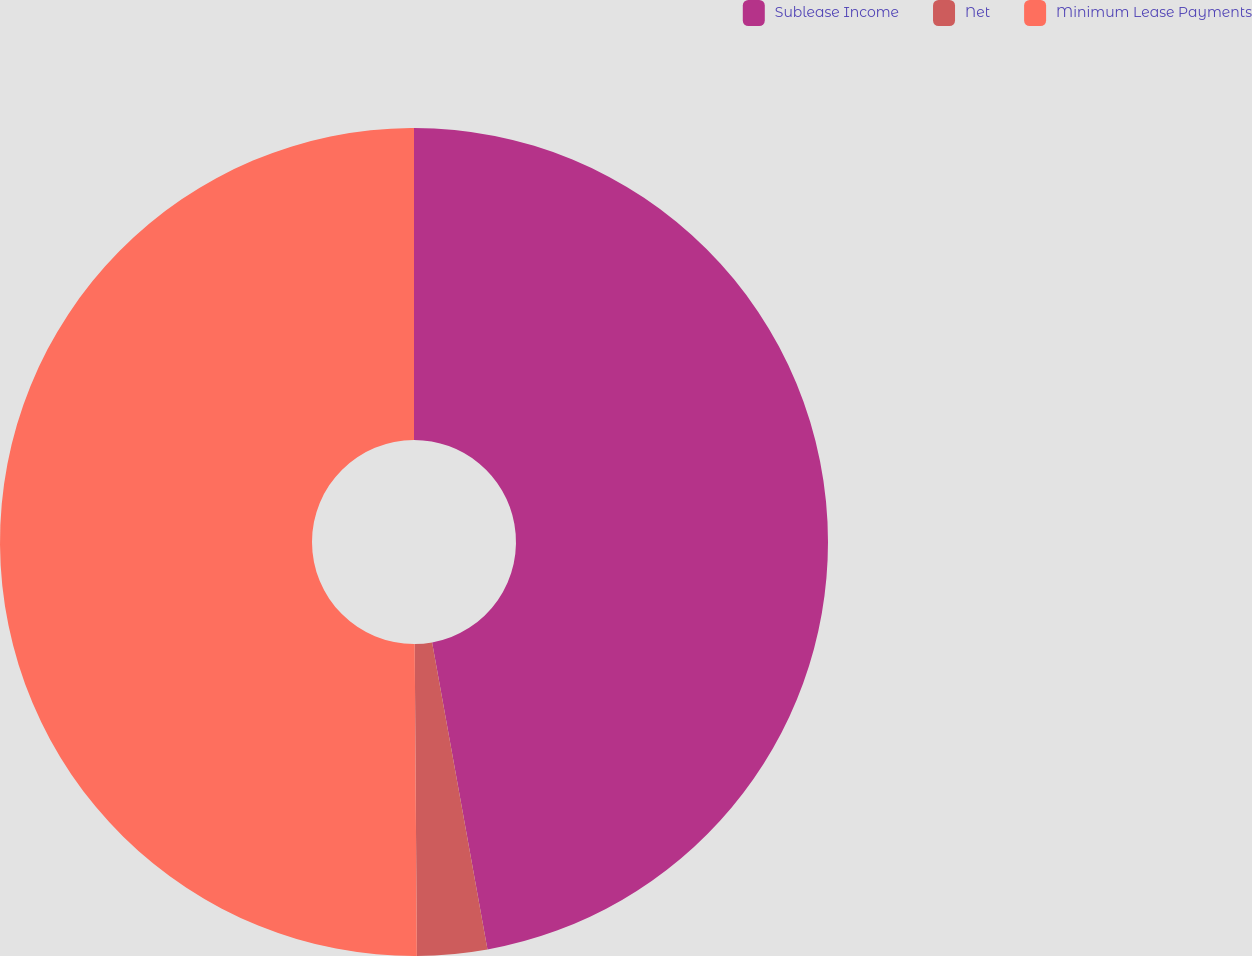<chart> <loc_0><loc_0><loc_500><loc_500><pie_chart><fcel>Sublease Income<fcel>Net<fcel>Minimum Lease Payments<nl><fcel>47.16%<fcel>2.73%<fcel>50.11%<nl></chart> 